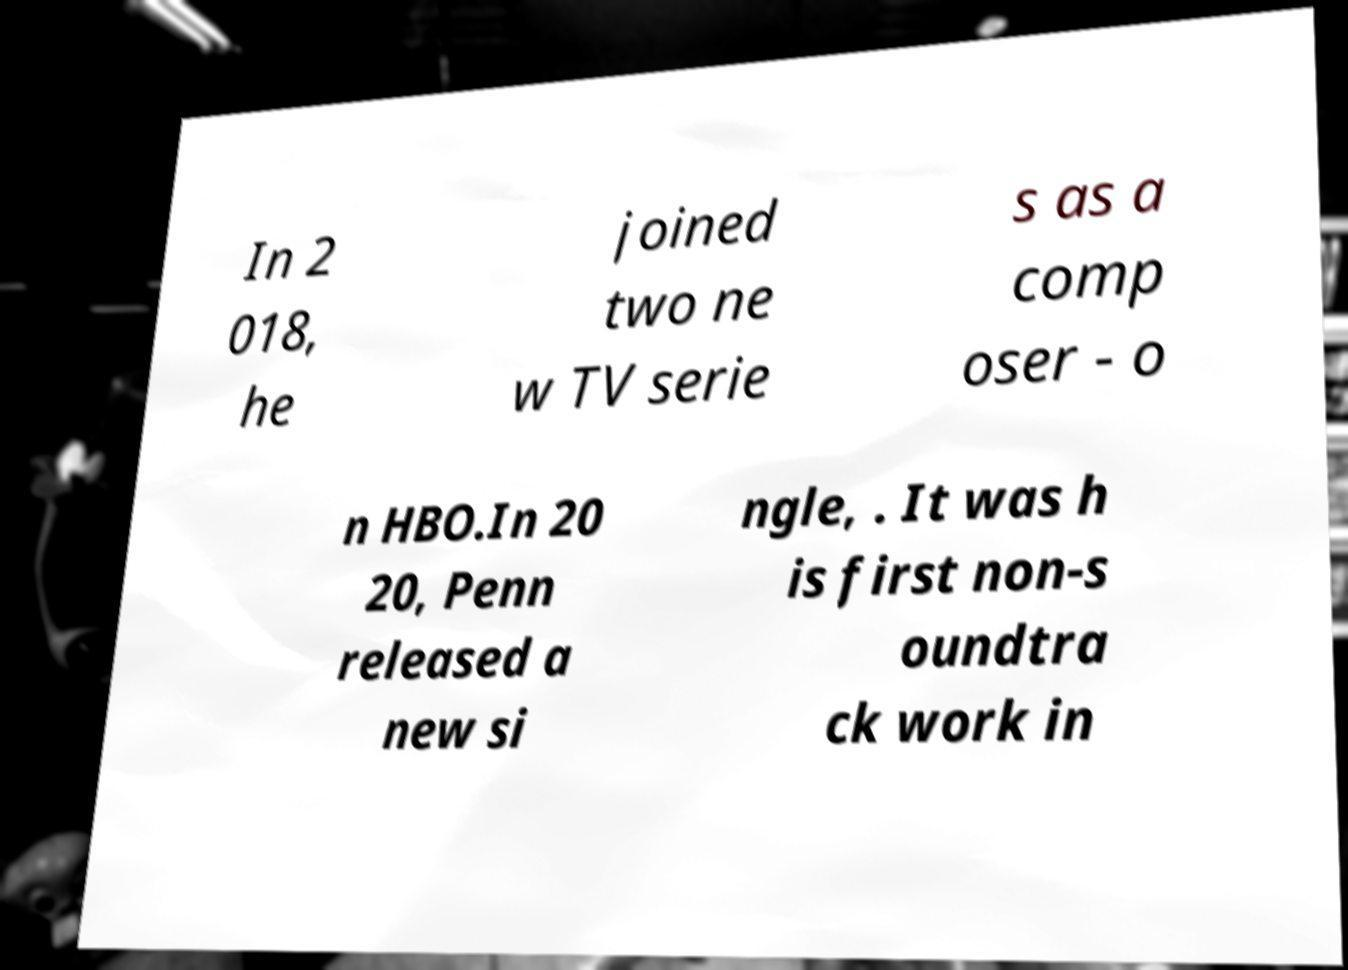There's text embedded in this image that I need extracted. Can you transcribe it verbatim? In 2 018, he joined two ne w TV serie s as a comp oser - o n HBO.In 20 20, Penn released a new si ngle, . It was h is first non-s oundtra ck work in 